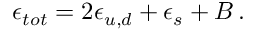Convert formula to latex. <formula><loc_0><loc_0><loc_500><loc_500>\epsilon _ { t o t } = 2 \epsilon _ { u , d } + \epsilon _ { s } + B \, .</formula> 